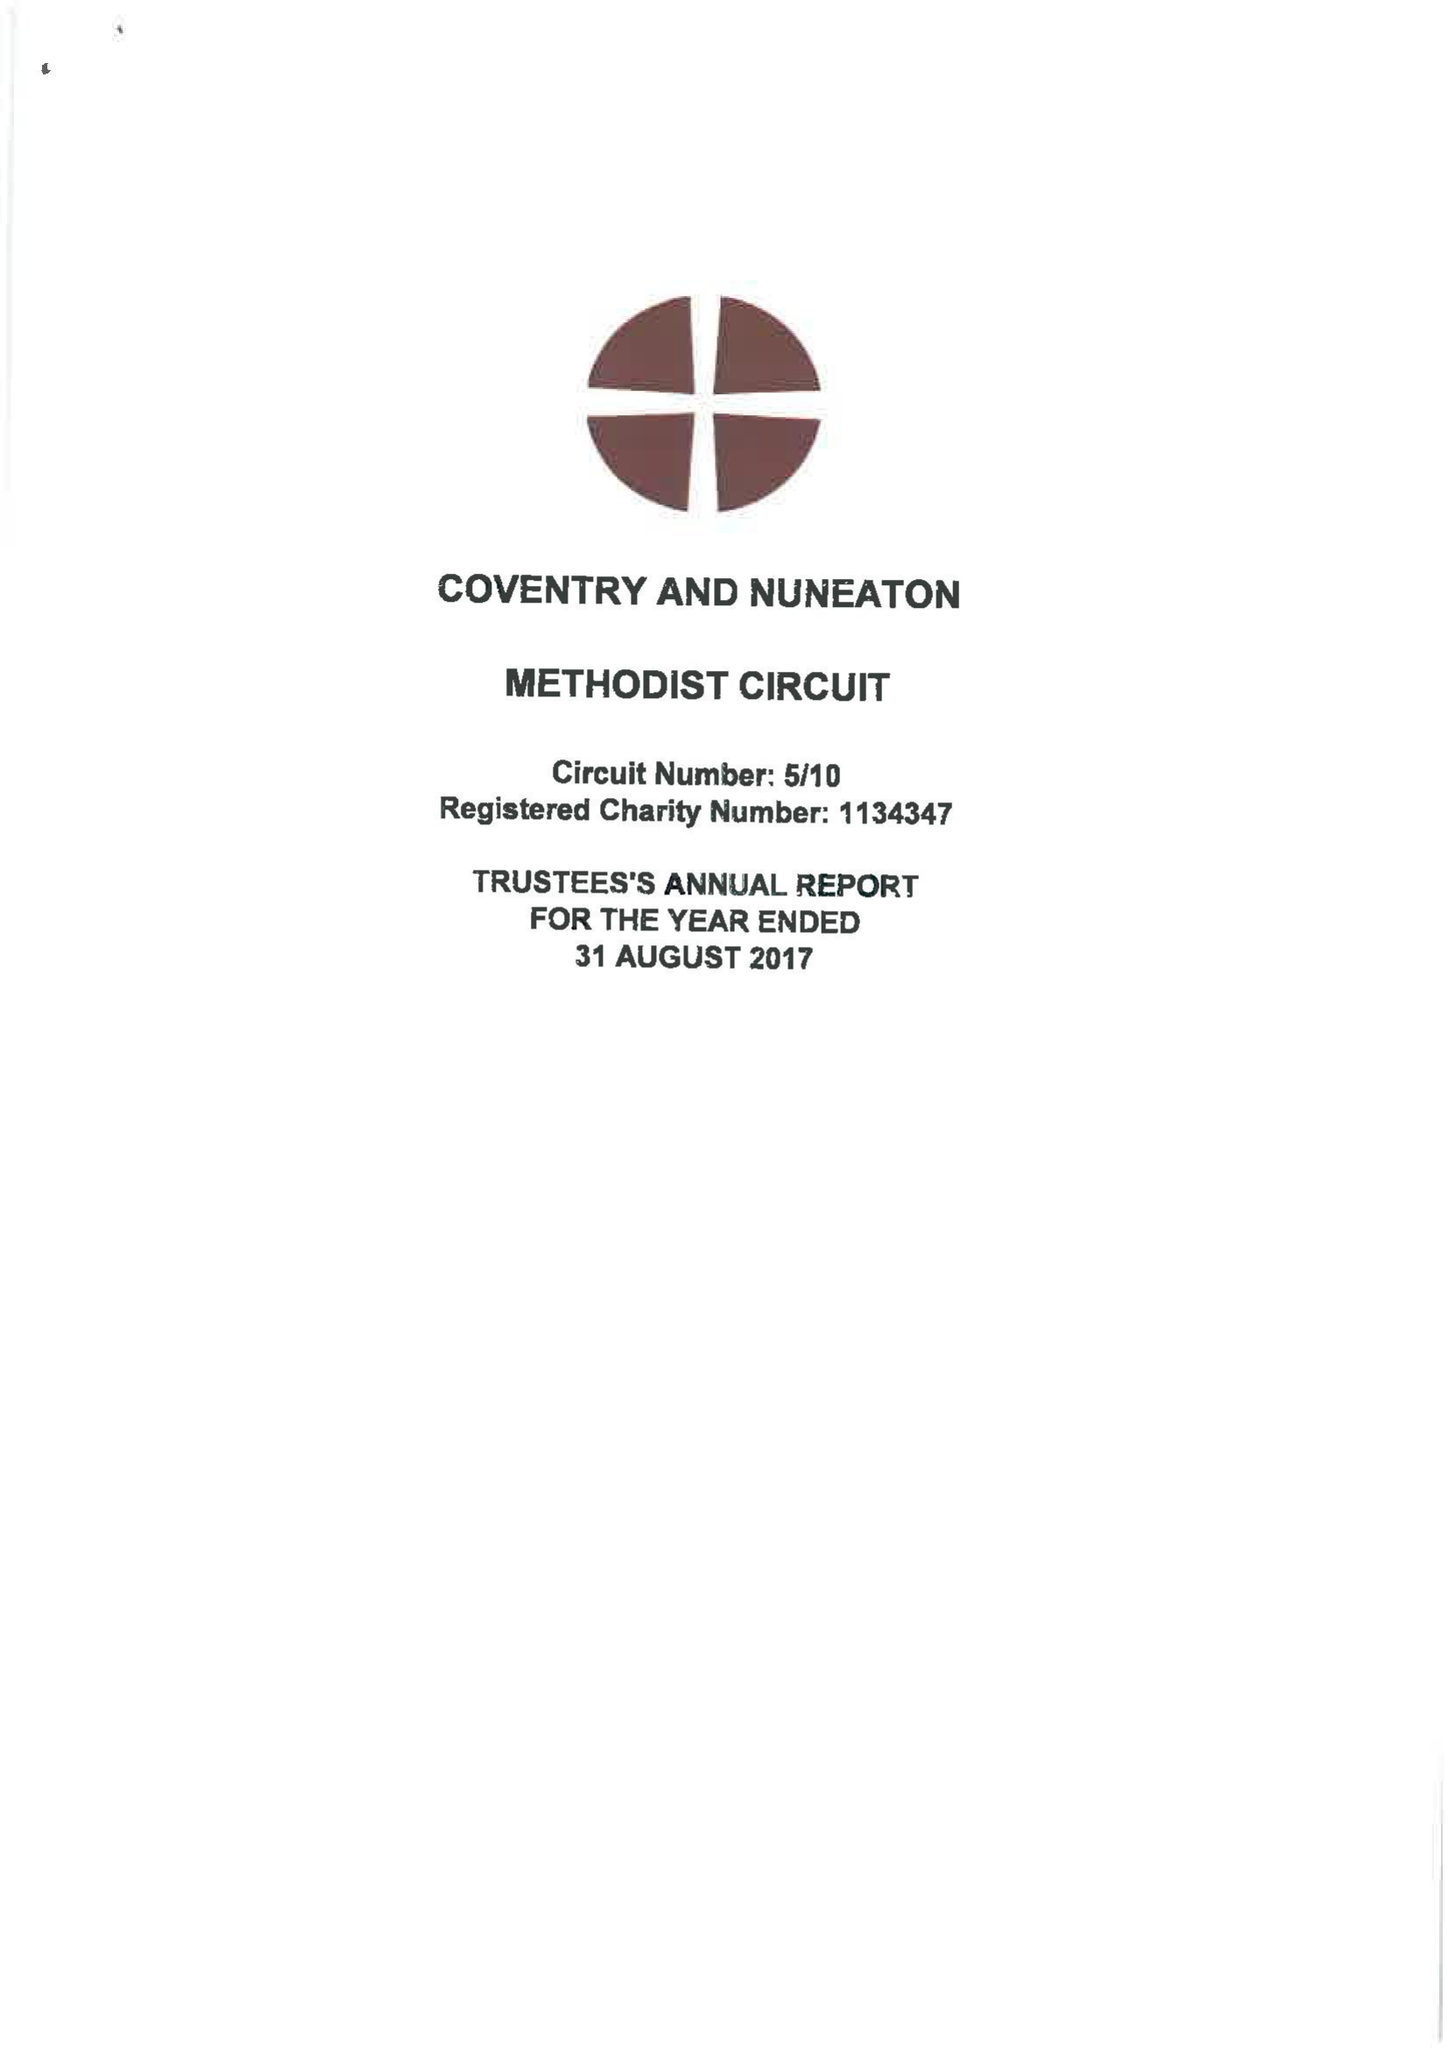What is the value for the address__street_line?
Answer the question using a single word or phrase. WARWICK LANE 